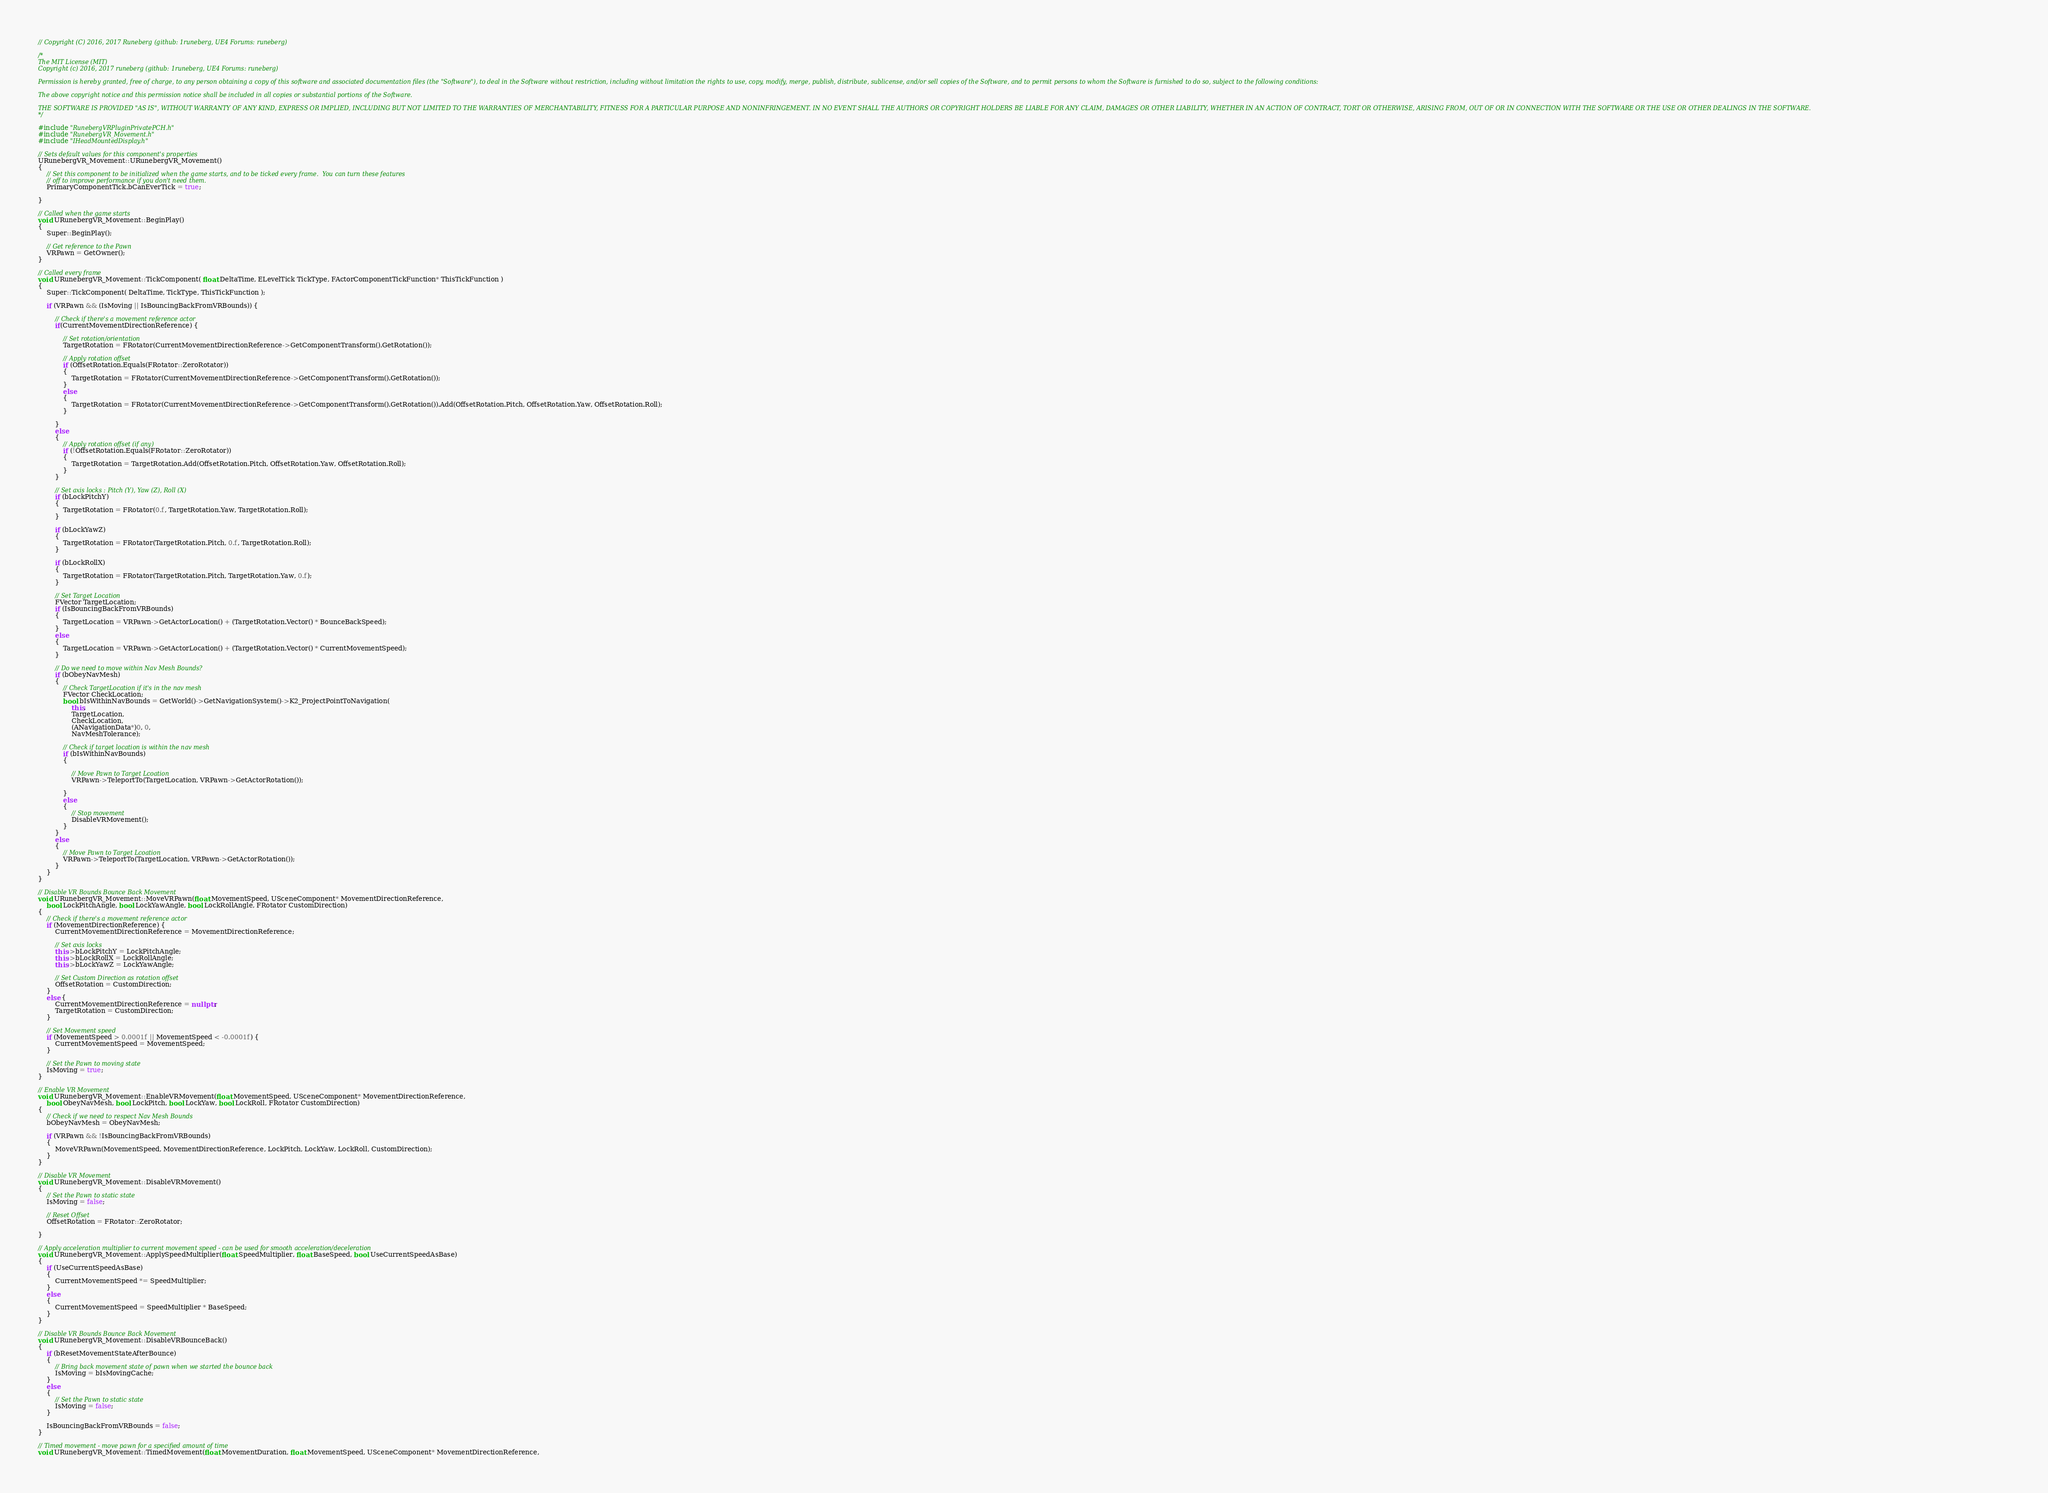<code> <loc_0><loc_0><loc_500><loc_500><_C++_>// Copyright (C) 2016, 2017 Runeberg (github: 1runeberg, UE4 Forums: runeberg)

/*
The MIT License (MIT)
Copyright (c) 2016, 2017 runeberg (github: 1runeberg, UE4 Forums: runeberg)

Permission is hereby granted, free of charge, to any person obtaining a copy of this software and associated documentation files (the "Software"), to deal in the Software without restriction, including without limitation the rights to use, copy, modify, merge, publish, distribute, sublicense, and/or sell copies of the Software, and to permit persons to whom the Software is furnished to do so, subject to the following conditions:

The above copyright notice and this permission notice shall be included in all copies or substantial portions of the Software.

THE SOFTWARE IS PROVIDED "AS IS", WITHOUT WARRANTY OF ANY KIND, EXPRESS OR IMPLIED, INCLUDING BUT NOT LIMITED TO THE WARRANTIES OF MERCHANTABILITY, FITNESS FOR A PARTICULAR PURPOSE AND NONINFRINGEMENT. IN NO EVENT SHALL THE AUTHORS OR COPYRIGHT HOLDERS BE LIABLE FOR ANY CLAIM, DAMAGES OR OTHER LIABILITY, WHETHER IN AN ACTION OF CONTRACT, TORT OR OTHERWISE, ARISING FROM, OUT OF OR IN CONNECTION WITH THE SOFTWARE OR THE USE OR OTHER DEALINGS IN THE SOFTWARE.
*/

#include "RunebergVRPluginPrivatePCH.h"
#include "RunebergVR_Movement.h"
#include "IHeadMountedDisplay.h"

// Sets default values for this component's properties
URunebergVR_Movement::URunebergVR_Movement()
{
	// Set this component to be initialized when the game starts, and to be ticked every frame.  You can turn these features
	// off to improve performance if you don't need them.
	PrimaryComponentTick.bCanEverTick = true;

}

// Called when the game starts
void URunebergVR_Movement::BeginPlay()
{
	Super::BeginPlay();

	// Get reference to the Pawn
	VRPawn = GetOwner();
}

// Called every frame
void URunebergVR_Movement::TickComponent( float DeltaTime, ELevelTick TickType, FActorComponentTickFunction* ThisTickFunction )
{
	Super::TickComponent( DeltaTime, TickType, ThisTickFunction );

	if (VRPawn && (IsMoving || IsBouncingBackFromVRBounds)) {

		// Check if there's a movement reference actor
		if(CurrentMovementDirectionReference) {

			// Set rotation/orientation
			TargetRotation = FRotator(CurrentMovementDirectionReference->GetComponentTransform().GetRotation());

			// Apply rotation offset
			if (OffsetRotation.Equals(FRotator::ZeroRotator))
			{
				TargetRotation = FRotator(CurrentMovementDirectionReference->GetComponentTransform().GetRotation());
			}
			else 
			{
				TargetRotation = FRotator(CurrentMovementDirectionReference->GetComponentTransform().GetRotation()).Add(OffsetRotation.Pitch, OffsetRotation.Yaw, OffsetRotation.Roll);
			}

		}
		else 
		{
			// Apply rotation offset (if any)
			if (!OffsetRotation.Equals(FRotator::ZeroRotator))
			{
				TargetRotation = TargetRotation.Add(OffsetRotation.Pitch, OffsetRotation.Yaw, OffsetRotation.Roll);
			}
		}

		// Set axis locks : Pitch (Y), Yaw (Z), Roll (X)
		if (bLockPitchY)
		{
			TargetRotation = FRotator(0.f, TargetRotation.Yaw, TargetRotation.Roll);
		}

		if (bLockYawZ)
		{
			TargetRotation = FRotator(TargetRotation.Pitch, 0.f, TargetRotation.Roll);
		}

		if (bLockRollX)
		{
			TargetRotation = FRotator(TargetRotation.Pitch, TargetRotation.Yaw, 0.f);
		}

		// Set Target Location
		FVector TargetLocation;
		if (IsBouncingBackFromVRBounds)
		{
			TargetLocation = VRPawn->GetActorLocation() + (TargetRotation.Vector() * BounceBackSpeed);
		}
		else
		{
			TargetLocation = VRPawn->GetActorLocation() + (TargetRotation.Vector() * CurrentMovementSpeed);
		}
		
		// Do we need to move within Nav Mesh Bounds?
		if (bObeyNavMesh)
		{
			// Check TargetLocation if it's in the nav mesh
			FVector CheckLocation;
			bool bIsWithinNavBounds = GetWorld()->GetNavigationSystem()->K2_ProjectPointToNavigation(
				this,
				TargetLocation,
				CheckLocation,
				(ANavigationData*)0, 0,
				NavMeshTolerance);

			// Check if target location is within the nav mesh
			if (bIsWithinNavBounds)
			{

				// Move Pawn to Target Lcoation
				VRPawn->TeleportTo(TargetLocation, VRPawn->GetActorRotation());
				
			}
			else
			{
				// Stop movement
				DisableVRMovement();
			}
		}
		else 
		{
			// Move Pawn to Target Lcoation
			VRPawn->TeleportTo(TargetLocation, VRPawn->GetActorRotation());
		}
	}
}

// Disable VR Bounds Bounce Back Movement
void URunebergVR_Movement::MoveVRPawn(float MovementSpeed, USceneComponent* MovementDirectionReference,  
	bool LockPitchAngle, bool LockYawAngle, bool LockRollAngle, FRotator CustomDirection)
{
	// Check if there's a movement reference actor
	if (MovementDirectionReference) {
		CurrentMovementDirectionReference = MovementDirectionReference;

		// Set axis locks
		this->bLockPitchY = LockPitchAngle;
		this->bLockRollX = LockRollAngle;
		this->bLockYawZ = LockYawAngle;

		// Set Custom Direction as rotation offset
		OffsetRotation = CustomDirection;
	}
	else {
		CurrentMovementDirectionReference = nullptr;
		TargetRotation = CustomDirection;
	}

	// Set Movement speed
	if (MovementSpeed > 0.0001f || MovementSpeed < -0.0001f) {
		CurrentMovementSpeed = MovementSpeed;
	}

	// Set the Pawn to moving state
	IsMoving = true;
}

// Enable VR Movement
void URunebergVR_Movement::EnableVRMovement(float MovementSpeed, USceneComponent* MovementDirectionReference,
	bool ObeyNavMesh, bool LockPitch, bool LockYaw, bool LockRoll, FRotator CustomDirection)
{
	// Check if we need to respect Nav Mesh Bounds
	bObeyNavMesh = ObeyNavMesh;

	if (VRPawn && !IsBouncingBackFromVRBounds) 
	{
		MoveVRPawn(MovementSpeed, MovementDirectionReference, LockPitch, LockYaw, LockRoll, CustomDirection);
	}
}

// Disable VR Movement
void URunebergVR_Movement::DisableVRMovement()
{
	// Set the Pawn to static state
	IsMoving = false;

	// Reset Offset
	OffsetRotation = FRotator::ZeroRotator;

}

// Apply acceleration multiplier to current movement speed - can be used for smooth acceleration/deceleration
void URunebergVR_Movement::ApplySpeedMultiplier(float SpeedMultiplier, float BaseSpeed, bool UseCurrentSpeedAsBase)
{
	if (UseCurrentSpeedAsBase)
	{
		CurrentMovementSpeed *= SpeedMultiplier;
	}
	else 
	{
		CurrentMovementSpeed = SpeedMultiplier * BaseSpeed;
	}
}

// Disable VR Bounds Bounce Back Movement
void URunebergVR_Movement::DisableVRBounceBack()
{
	if (bResetMovementStateAfterBounce)
	{
		// Bring back movement state of pawn when we started the bounce back
		IsMoving = bIsMovingCache;
	}
	else 
	{
		// Set the Pawn to static state
		IsMoving = false;
	}

	IsBouncingBackFromVRBounds = false;
}

// Timed movement - move pawn for a specified amount of time
void URunebergVR_Movement::TimedMovement(float MovementDuration, float MovementSpeed, USceneComponent* MovementDirectionReference, </code> 